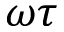<formula> <loc_0><loc_0><loc_500><loc_500>\omega \tau</formula> 